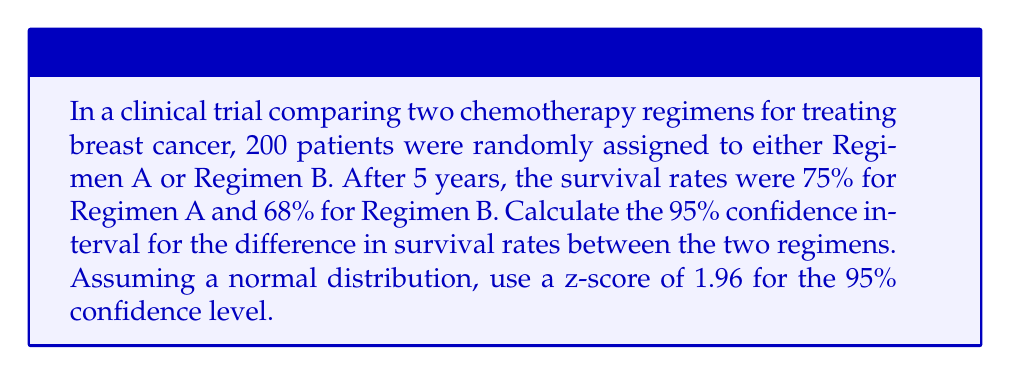Give your solution to this math problem. To calculate the confidence interval for the difference in survival rates, we'll follow these steps:

1. Calculate the standard error of the difference in proportions:
   Let $p_A = 0.75$ (survival rate for Regimen A)
   Let $p_B = 0.68$ (survival rate for Regimen B)
   Let $n_A = n_B = 100$ (assuming equal distribution of patients)

   The standard error (SE) is given by:
   
   $$SE = \sqrt{\frac{p_A(1-p_A)}{n_A} + \frac{p_B(1-p_B)}{n_B}}$$

   $$SE = \sqrt{\frac{0.75(1-0.75)}{100} + \frac{0.68(1-0.68)}{100}}$$
   
   $$SE = \sqrt{0.001875 + 0.002176} = \sqrt{0.004051} = 0.0636$$

2. Calculate the difference in proportions:
   $p_A - p_B = 0.75 - 0.68 = 0.07$

3. Calculate the margin of error:
   Margin of Error = z-score * SE
   $ME = 1.96 * 0.0636 = 0.1247$

4. Calculate the confidence interval:
   Lower bound = (Difference in proportions) - (Margin of Error)
   Upper bound = (Difference in proportions) + (Margin of Error)

   Lower bound = $0.07 - 0.1247 = -0.0547$
   Upper bound = $0.07 + 0.1247 = 0.1947$

Therefore, the 95% confidence interval for the difference in survival rates is (-0.0547, 0.1947) or approximately (-5.47%, 19.47%).
Answer: The 95% confidence interval for the difference in survival rates between Regimen A and Regimen B is (-0.0547, 0.1947) or (-5.47%, 19.47%). 